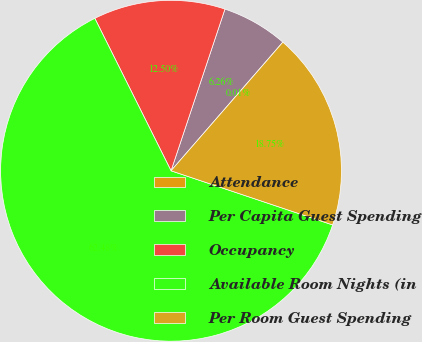Convert chart. <chart><loc_0><loc_0><loc_500><loc_500><pie_chart><fcel>Attendance<fcel>Per Capita Guest Spending<fcel>Occupancy<fcel>Available Room Nights (in<fcel>Per Room Guest Spending<nl><fcel>0.01%<fcel>6.26%<fcel>12.5%<fcel>62.47%<fcel>18.75%<nl></chart> 